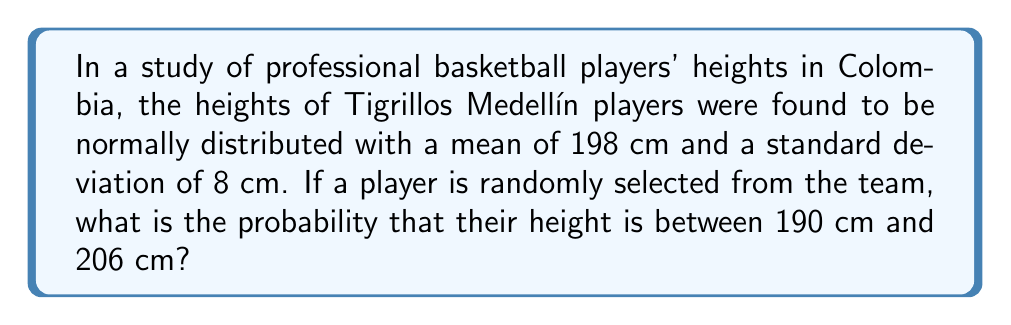Can you answer this question? Let's approach this step-by-step:

1) We're dealing with a normal distribution where:
   $\mu = 198$ cm (mean)
   $\sigma = 8$ cm (standard deviation)

2) We need to find $P(190 < X < 206)$, where $X$ is the height of a randomly selected player.

3) To solve this, we need to standardize these values using the z-score formula:
   $z = \frac{x - \mu}{\sigma}$

4) For the lower bound (190 cm):
   $z_1 = \frac{190 - 198}{8} = -1$

5) For the upper bound (206 cm):
   $z_2 = \frac{206 - 198}{8} = 1$

6) Now, we need to find $P(-1 < Z < 1)$, where $Z$ is the standard normal variable.

7) Using the standard normal distribution table or a calculator:
   $P(Z < 1) = 0.8413$
   $P(Z < -1) = 0.1587$

8) Therefore:
   $P(-1 < Z < 1) = P(Z < 1) - P(Z < -1)$
   $= 0.8413 - 0.1587 = 0.6826$

9) Convert to a percentage: $0.6826 \times 100\% = 68.26\%$
Answer: 68.26% 